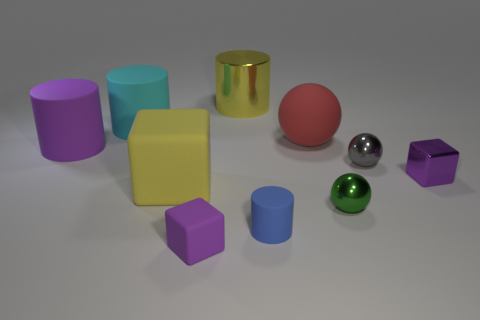Subtract all large cyan matte cylinders. How many cylinders are left? 3 Subtract all gray spheres. How many spheres are left? 2 Subtract all cyan cylinders. How many purple blocks are left? 2 Add 9 blue rubber objects. How many blue rubber objects exist? 10 Subtract 1 yellow cylinders. How many objects are left? 9 Subtract all cylinders. How many objects are left? 6 Subtract 2 cubes. How many cubes are left? 1 Subtract all cyan cylinders. Subtract all brown blocks. How many cylinders are left? 3 Subtract all small red blocks. Subtract all purple cubes. How many objects are left? 8 Add 7 big purple cylinders. How many big purple cylinders are left? 8 